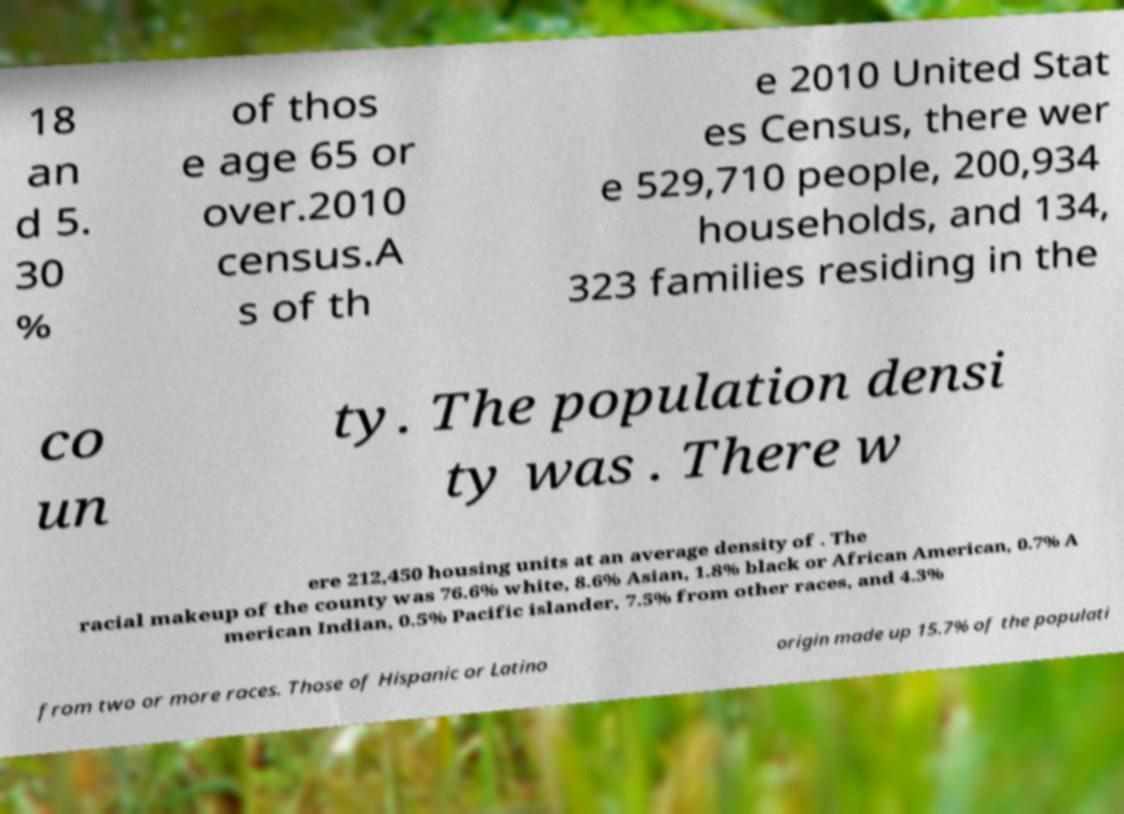For documentation purposes, I need the text within this image transcribed. Could you provide that? 18 an d 5. 30 % of thos e age 65 or over.2010 census.A s of th e 2010 United Stat es Census, there wer e 529,710 people, 200,934 households, and 134, 323 families residing in the co un ty. The population densi ty was . There w ere 212,450 housing units at an average density of . The racial makeup of the county was 76.6% white, 8.6% Asian, 1.8% black or African American, 0.7% A merican Indian, 0.5% Pacific islander, 7.5% from other races, and 4.3% from two or more races. Those of Hispanic or Latino origin made up 15.7% of the populati 